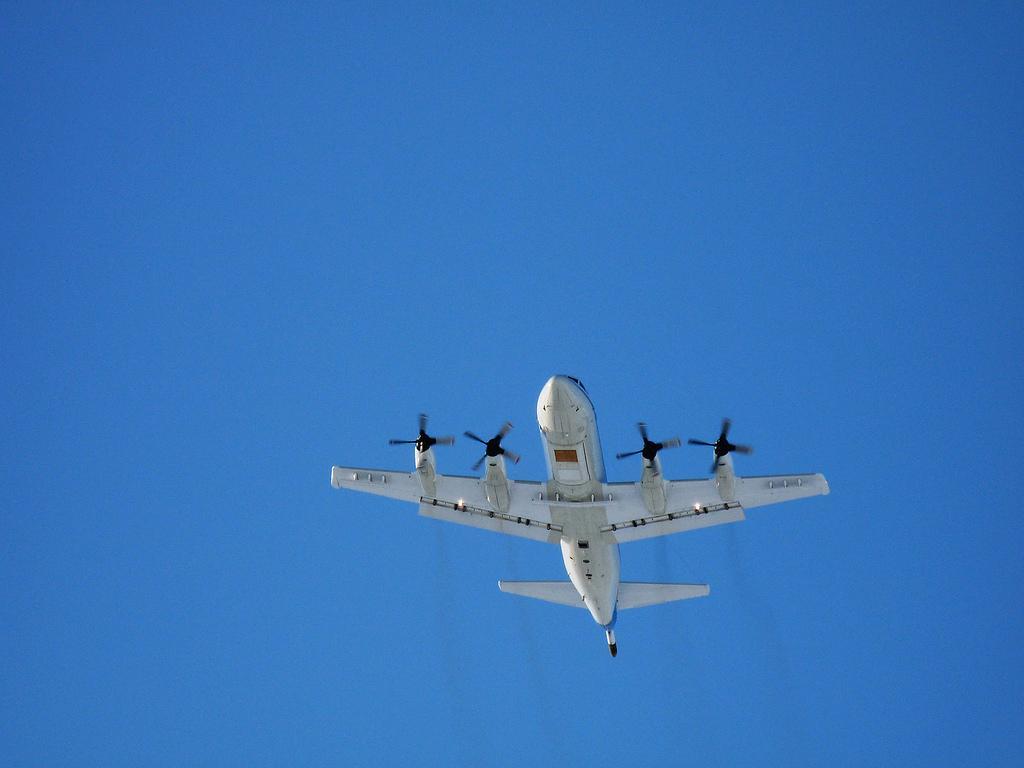In one or two sentences, can you explain what this image depicts? In this picture we can see an airplane flying in the sky. 